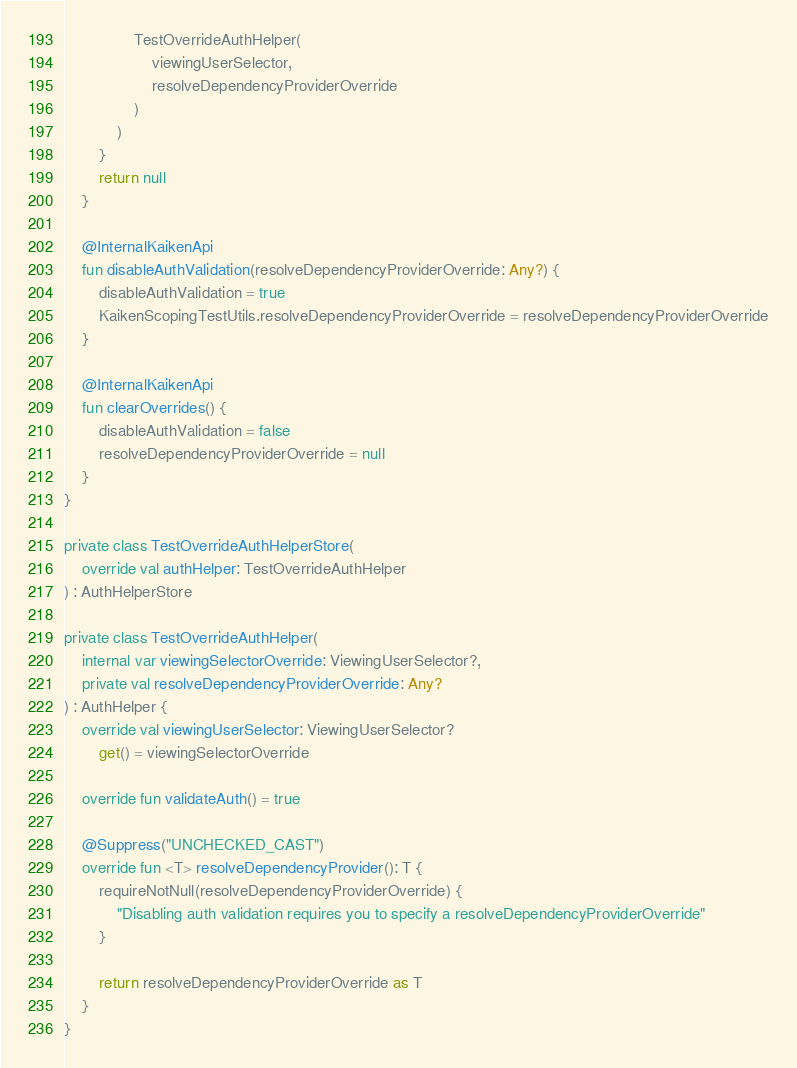Convert code to text. <code><loc_0><loc_0><loc_500><loc_500><_Kotlin_>                TestOverrideAuthHelper(
                    viewingUserSelector,
                    resolveDependencyProviderOverride
                )
            )
        }
        return null
    }

    @InternalKaikenApi
    fun disableAuthValidation(resolveDependencyProviderOverride: Any?) {
        disableAuthValidation = true
        KaikenScopingTestUtils.resolveDependencyProviderOverride = resolveDependencyProviderOverride
    }

    @InternalKaikenApi
    fun clearOverrides() {
        disableAuthValidation = false
        resolveDependencyProviderOverride = null
    }
}

private class TestOverrideAuthHelperStore(
    override val authHelper: TestOverrideAuthHelper
) : AuthHelperStore

private class TestOverrideAuthHelper(
    internal var viewingSelectorOverride: ViewingUserSelector?,
    private val resolveDependencyProviderOverride: Any?
) : AuthHelper {
    override val viewingUserSelector: ViewingUserSelector?
        get() = viewingSelectorOverride

    override fun validateAuth() = true

    @Suppress("UNCHECKED_CAST")
    override fun <T> resolveDependencyProvider(): T {
        requireNotNull(resolveDependencyProviderOverride) {
            "Disabling auth validation requires you to specify a resolveDependencyProviderOverride"
        }

        return resolveDependencyProviderOverride as T
    }
}
</code> 